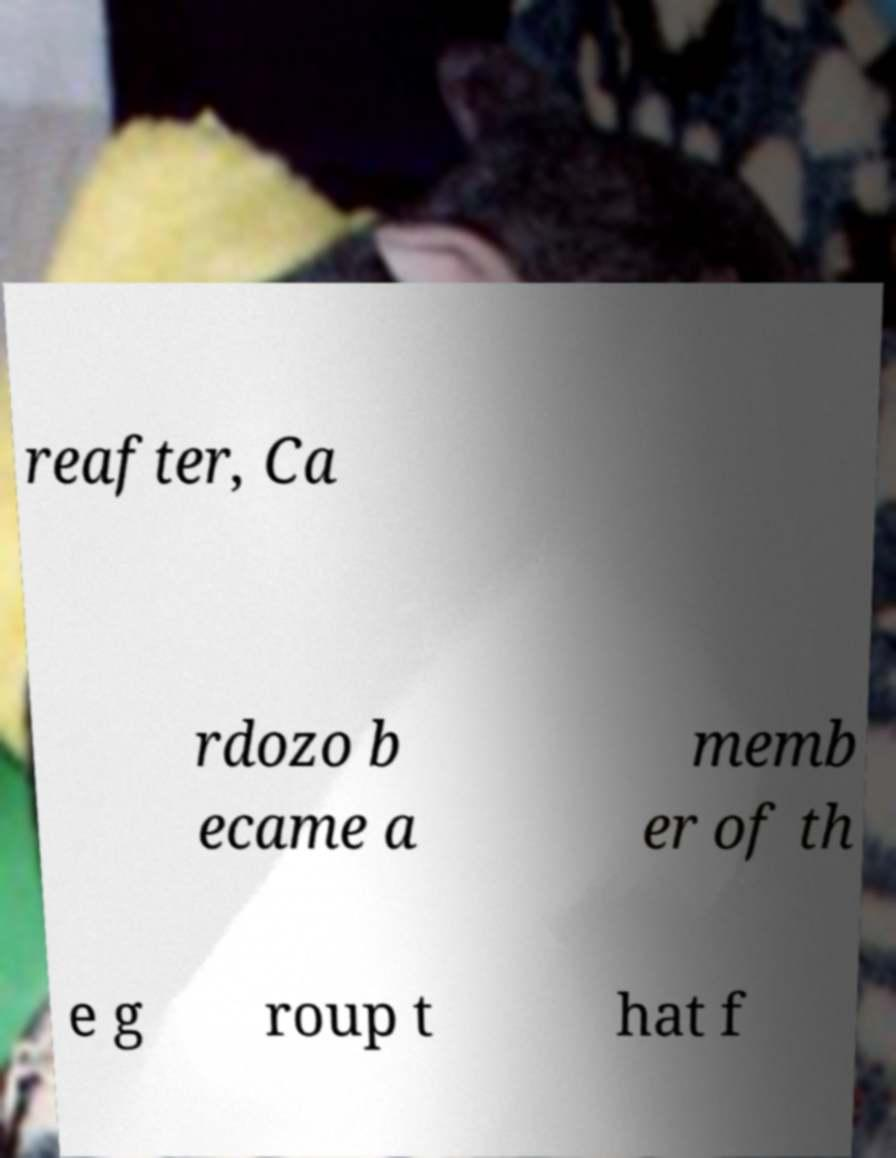Please identify and transcribe the text found in this image. reafter, Ca rdozo b ecame a memb er of th e g roup t hat f 